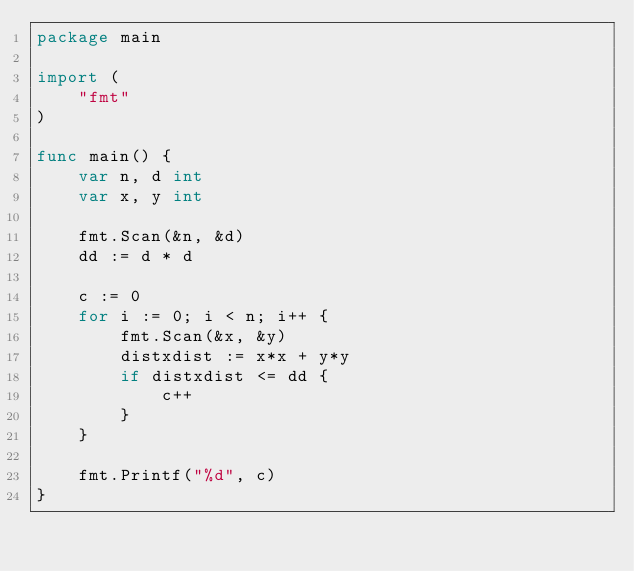<code> <loc_0><loc_0><loc_500><loc_500><_Go_>package main

import (
	"fmt"
)

func main() {
	var n, d int
	var x, y int

	fmt.Scan(&n, &d)
	dd := d * d

	c := 0
	for i := 0; i < n; i++ {
		fmt.Scan(&x, &y)
		distxdist := x*x + y*y
		if distxdist <= dd {
			c++
		}
	}

	fmt.Printf("%d", c)
}
</code> 